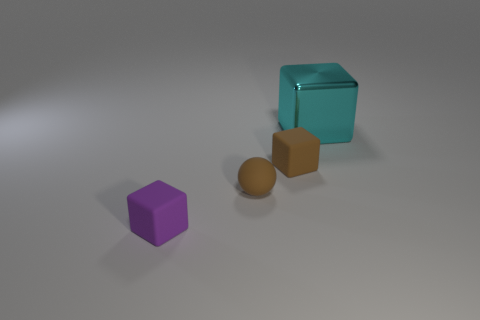The object that is left of the cyan cube and on the right side of the small brown ball has what shape?
Make the answer very short. Cube. The other tiny object that is the same shape as the small purple object is what color?
Provide a short and direct response. Brown. How many things are blocks on the left side of the big object or cyan metal objects that are on the right side of the tiny sphere?
Give a very brief answer. 3. How many brown balls are made of the same material as the brown block?
Make the answer very short. 1. The large metal object has what color?
Give a very brief answer. Cyan. There is a matte block that is the same size as the purple matte thing; what is its color?
Your answer should be compact. Brown. Are there any metallic objects of the same color as the small ball?
Your answer should be very brief. No. Is the shape of the tiny brown object to the left of the small brown cube the same as the object to the right of the brown cube?
Your answer should be very brief. No. What size is the thing that is the same color as the small ball?
Provide a short and direct response. Small. How many other objects are the same size as the cyan metallic object?
Your response must be concise. 0. 